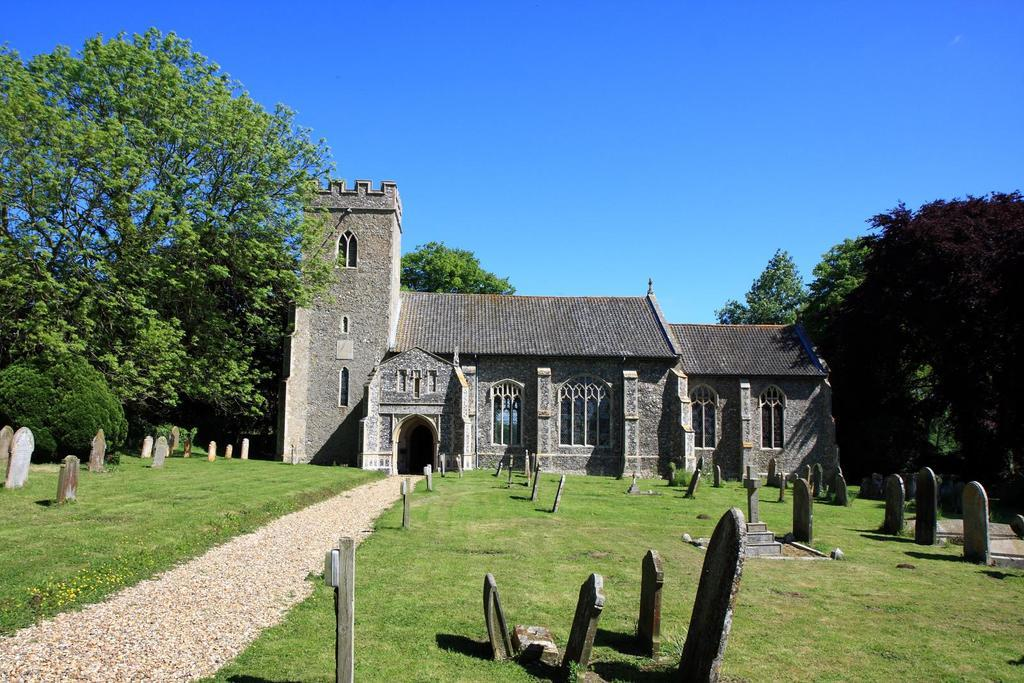What can be seen on the ground in the image? There are grave stones on the ground in the image. What type of path is present in the image? There is a walking path in the image. What structure is visible in the image? There is a building in the image. What type of vegetation is present in the image? There are trees and bushes in the image. What is visible in the background of the image? The sky is visible in the image. Can you see a baseball game happening in the image? There is no baseball game present in the image. Is there a donkey pulling a plough in the image? There is no donkey or plough present in the image. 